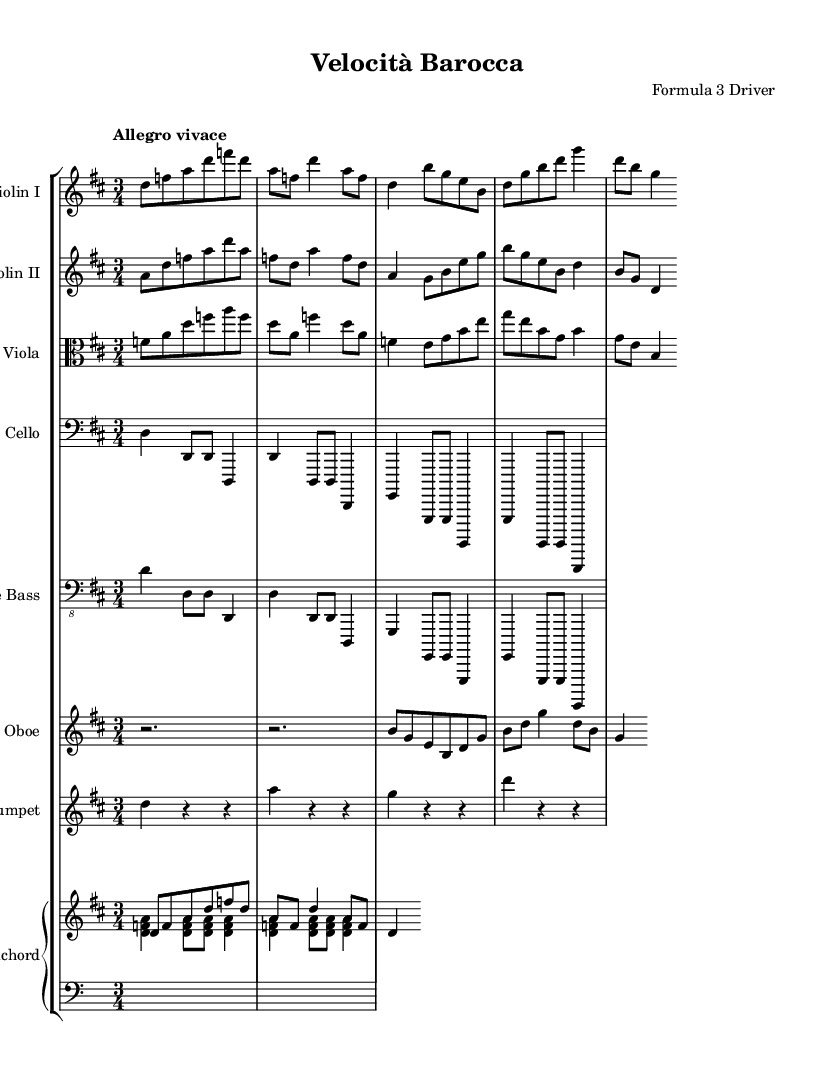What is the key signature of this music? The key signature is indicated at the beginning of the piece, showing two sharps, which signifies D major.
Answer: D major What is the time signature of this piece? The time signature is located next to the key signature, displaying a 3 over 4, which indicates a three-quarter time.
Answer: 3/4 What is the tempo marking of this composition? The tempo marking appears at the beginning, stating "Allegro vivace," which means to play at a fast and lively pace.
Answer: Allegro vivace Which instrument plays the melody in the first few measures? The sheet music reveals that the Violin I part carries the melody initially, indicated by the clefs and note arrangement.
Answer: Violin I How many sections does the music appear to have based on the structure? Analyzing the layout of the parts and their arrangement, we notice that the piece has two broad sections for the strings and winds, suggesting a binary form typical of orchestral suites.
Answer: Two sections What instruments are included in the orchestration? By looking at the score, we can count the distinct parts labeled, which include Violin I, Violin II, Viola, Cello, Double Bass, Oboe, Trumpet, and Harpsichord.
Answer: Eight instruments How does the harpsichord contribute to the overall texture of the music? The harpsichord plays both harmonic and rhythmic roles through chords and thematic accompaniment, supporting the strings and woodwinds, providing a rich texture typical of Baroque music.
Answer: Harmonic and rhythmic 